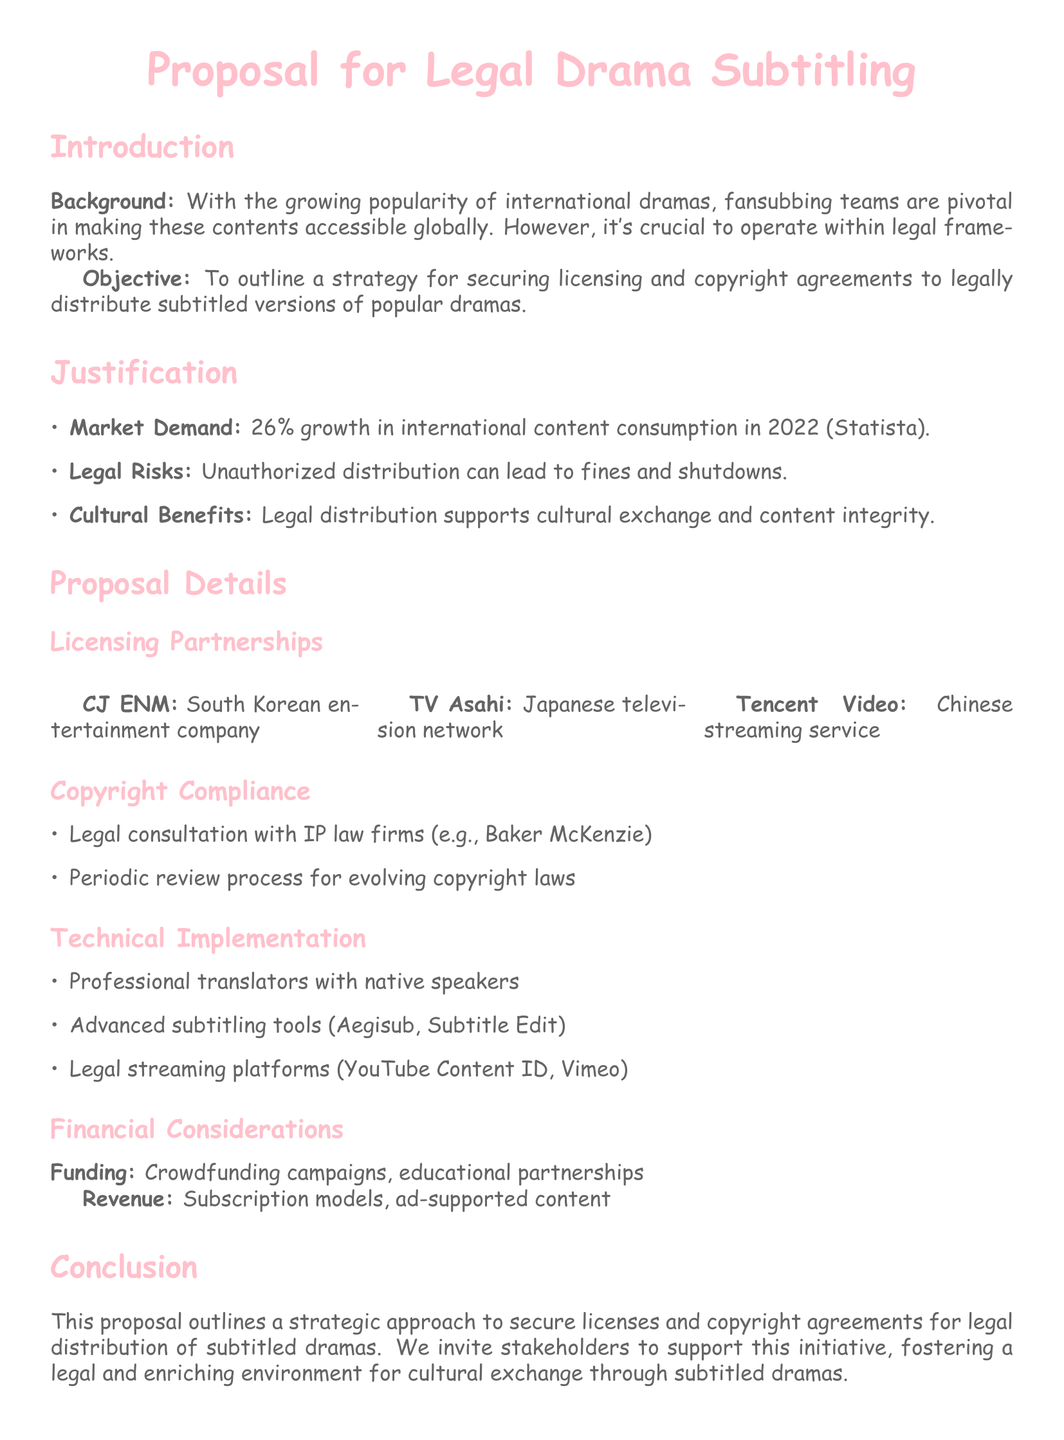What is the proposal's objective? The proposal's objective is to outline a strategy for securing licensing and copyright agreements to legally distribute subtitled versions of popular dramas.
Answer: To outline a strategy for securing licensing and copyright agreements What percentage did international content consumption grow in 2022? The document states that there was a 26% growth in international content consumption in 2022.
Answer: 26% Which South Korean company is mentioned as a potential licensing partner? The proposal lists CJ ENM as a South Korean entertainment company for licensing partnerships.
Answer: CJ ENM What is the name of the Japanese television network included in the proposal? TV Asahi is mentioned as a Japanese television network in the licensing partnerships section.
Answer: TV Asahi What is one funding source mentioned for the financial considerations? The proposal indicates that crowdfunding campaigns are one of the funding sources considered for financing.
Answer: Crowdfunding campaigns What type of legal consultation is advised in the proposal? The proposal advises legal consultation with IP law firms, specifically mentioning Baker McKenzie.
Answer: IP law firms What is one of the advanced subtitling tools listed in the document? The document lists Aegisub as one of the advanced subtitling tools recommended for technical implementation.
Answer: Aegisub Why is legal distribution important according to the proposal? Legal distribution supports cultural exchange and content integrity, as mentioned in the justification section.
Answer: Cultural exchange and content integrity What is a key risk associated with unauthorized distribution? The document states that unauthorized distribution can lead to fines and shutdowns.
Answer: Fines and shutdowns 